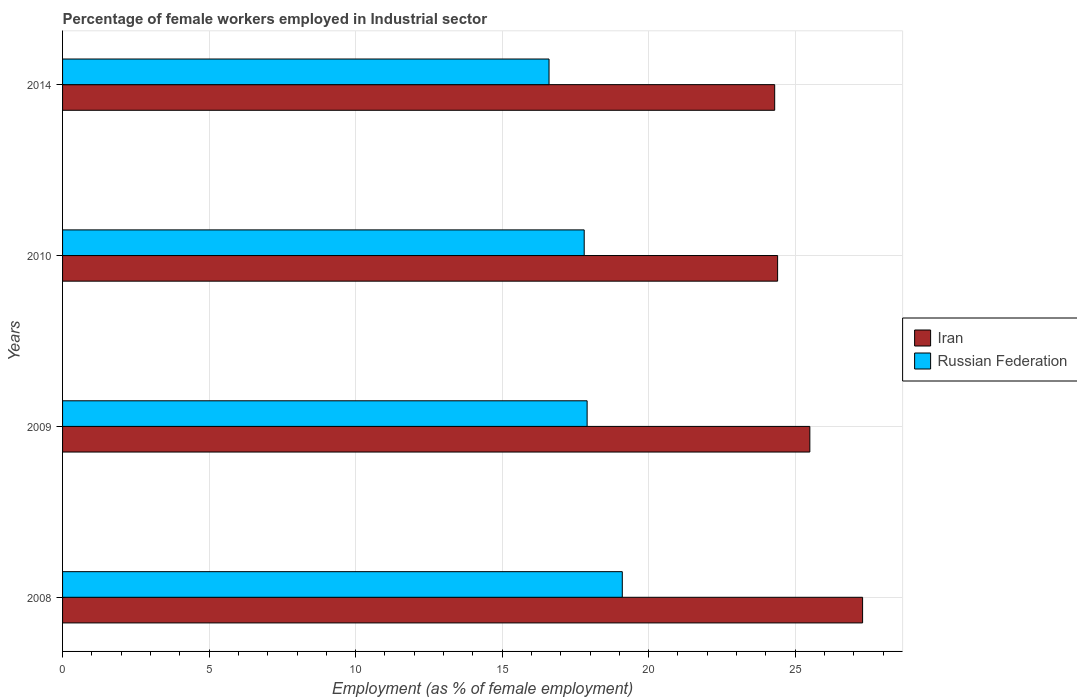Are the number of bars per tick equal to the number of legend labels?
Ensure brevity in your answer.  Yes. How many bars are there on the 3rd tick from the top?
Provide a succinct answer. 2. How many bars are there on the 2nd tick from the bottom?
Offer a terse response. 2. What is the percentage of females employed in Industrial sector in Iran in 2014?
Offer a terse response. 24.3. Across all years, what is the maximum percentage of females employed in Industrial sector in Russian Federation?
Give a very brief answer. 19.1. Across all years, what is the minimum percentage of females employed in Industrial sector in Iran?
Your response must be concise. 24.3. In which year was the percentage of females employed in Industrial sector in Iran maximum?
Keep it short and to the point. 2008. In which year was the percentage of females employed in Industrial sector in Iran minimum?
Ensure brevity in your answer.  2014. What is the total percentage of females employed in Industrial sector in Iran in the graph?
Your answer should be compact. 101.5. What is the difference between the percentage of females employed in Industrial sector in Iran in 2010 and that in 2014?
Ensure brevity in your answer.  0.1. What is the difference between the percentage of females employed in Industrial sector in Russian Federation in 2014 and the percentage of females employed in Industrial sector in Iran in 2008?
Offer a terse response. -10.7. What is the average percentage of females employed in Industrial sector in Iran per year?
Your answer should be compact. 25.37. In the year 2008, what is the difference between the percentage of females employed in Industrial sector in Iran and percentage of females employed in Industrial sector in Russian Federation?
Offer a terse response. 8.2. What is the ratio of the percentage of females employed in Industrial sector in Russian Federation in 2008 to that in 2014?
Your response must be concise. 1.15. What is the difference between the highest and the second highest percentage of females employed in Industrial sector in Russian Federation?
Your response must be concise. 1.2. What does the 2nd bar from the top in 2010 represents?
Offer a terse response. Iran. What does the 1st bar from the bottom in 2014 represents?
Your answer should be compact. Iran. Are all the bars in the graph horizontal?
Offer a terse response. Yes. How many years are there in the graph?
Keep it short and to the point. 4. What is the difference between two consecutive major ticks on the X-axis?
Your answer should be very brief. 5. Are the values on the major ticks of X-axis written in scientific E-notation?
Your answer should be very brief. No. Does the graph contain any zero values?
Give a very brief answer. No. Where does the legend appear in the graph?
Your answer should be very brief. Center right. How are the legend labels stacked?
Your response must be concise. Vertical. What is the title of the graph?
Provide a short and direct response. Percentage of female workers employed in Industrial sector. Does "Middle East & North Africa (all income levels)" appear as one of the legend labels in the graph?
Offer a terse response. No. What is the label or title of the X-axis?
Make the answer very short. Employment (as % of female employment). What is the Employment (as % of female employment) of Iran in 2008?
Your answer should be very brief. 27.3. What is the Employment (as % of female employment) of Russian Federation in 2008?
Your response must be concise. 19.1. What is the Employment (as % of female employment) of Iran in 2009?
Your response must be concise. 25.5. What is the Employment (as % of female employment) in Russian Federation in 2009?
Your response must be concise. 17.9. What is the Employment (as % of female employment) of Iran in 2010?
Provide a short and direct response. 24.4. What is the Employment (as % of female employment) in Russian Federation in 2010?
Offer a terse response. 17.8. What is the Employment (as % of female employment) in Iran in 2014?
Provide a succinct answer. 24.3. What is the Employment (as % of female employment) of Russian Federation in 2014?
Your answer should be very brief. 16.6. Across all years, what is the maximum Employment (as % of female employment) in Iran?
Your response must be concise. 27.3. Across all years, what is the maximum Employment (as % of female employment) of Russian Federation?
Offer a very short reply. 19.1. Across all years, what is the minimum Employment (as % of female employment) of Iran?
Your answer should be compact. 24.3. Across all years, what is the minimum Employment (as % of female employment) of Russian Federation?
Make the answer very short. 16.6. What is the total Employment (as % of female employment) of Iran in the graph?
Provide a short and direct response. 101.5. What is the total Employment (as % of female employment) of Russian Federation in the graph?
Offer a very short reply. 71.4. What is the difference between the Employment (as % of female employment) in Iran in 2008 and that in 2009?
Keep it short and to the point. 1.8. What is the difference between the Employment (as % of female employment) in Iran in 2008 and that in 2014?
Ensure brevity in your answer.  3. What is the difference between the Employment (as % of female employment) in Russian Federation in 2009 and that in 2010?
Make the answer very short. 0.1. What is the difference between the Employment (as % of female employment) of Iran in 2009 and that in 2014?
Your answer should be very brief. 1.2. What is the difference between the Employment (as % of female employment) in Russian Federation in 2010 and that in 2014?
Your answer should be compact. 1.2. What is the difference between the Employment (as % of female employment) of Iran in 2008 and the Employment (as % of female employment) of Russian Federation in 2010?
Offer a very short reply. 9.5. What is the difference between the Employment (as % of female employment) in Iran in 2009 and the Employment (as % of female employment) in Russian Federation in 2010?
Keep it short and to the point. 7.7. What is the difference between the Employment (as % of female employment) of Iran in 2010 and the Employment (as % of female employment) of Russian Federation in 2014?
Offer a terse response. 7.8. What is the average Employment (as % of female employment) in Iran per year?
Your answer should be compact. 25.38. What is the average Employment (as % of female employment) in Russian Federation per year?
Make the answer very short. 17.85. In the year 2014, what is the difference between the Employment (as % of female employment) of Iran and Employment (as % of female employment) of Russian Federation?
Offer a terse response. 7.7. What is the ratio of the Employment (as % of female employment) of Iran in 2008 to that in 2009?
Provide a short and direct response. 1.07. What is the ratio of the Employment (as % of female employment) of Russian Federation in 2008 to that in 2009?
Provide a short and direct response. 1.07. What is the ratio of the Employment (as % of female employment) in Iran in 2008 to that in 2010?
Offer a very short reply. 1.12. What is the ratio of the Employment (as % of female employment) of Russian Federation in 2008 to that in 2010?
Provide a succinct answer. 1.07. What is the ratio of the Employment (as % of female employment) in Iran in 2008 to that in 2014?
Your answer should be very brief. 1.12. What is the ratio of the Employment (as % of female employment) in Russian Federation in 2008 to that in 2014?
Offer a very short reply. 1.15. What is the ratio of the Employment (as % of female employment) of Iran in 2009 to that in 2010?
Make the answer very short. 1.05. What is the ratio of the Employment (as % of female employment) in Russian Federation in 2009 to that in 2010?
Offer a very short reply. 1.01. What is the ratio of the Employment (as % of female employment) of Iran in 2009 to that in 2014?
Your response must be concise. 1.05. What is the ratio of the Employment (as % of female employment) in Russian Federation in 2009 to that in 2014?
Your response must be concise. 1.08. What is the ratio of the Employment (as % of female employment) of Iran in 2010 to that in 2014?
Your response must be concise. 1. What is the ratio of the Employment (as % of female employment) in Russian Federation in 2010 to that in 2014?
Offer a terse response. 1.07. What is the difference between the highest and the second highest Employment (as % of female employment) of Iran?
Ensure brevity in your answer.  1.8. What is the difference between the highest and the lowest Employment (as % of female employment) in Iran?
Provide a short and direct response. 3. 